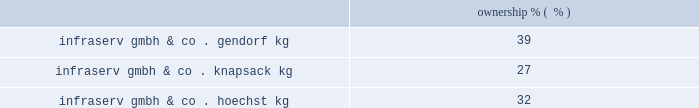Korea engineering plastics co. , ltd .
Founded in 1987 , kepco is the leading producer of pom in south korea .
Kepco is a venture between celanese's ticona business ( 50% ( 50 % ) ) , mitsubishi gas chemical company , inc .
( 40% ( 40 % ) ) and mitsubishi corporation ( 10% ( 10 % ) ) .
Kepco has polyacetal production facilities in ulsan , south korea , compounding facilities for pbt and nylon in pyongtaek , south korea , and participates with polyplastics and mitsubishi gas chemical company , inc .
In a world-scale pom facility in nantong , china .
Polyplastics co. , ltd .
Polyplastics is a leading supplier of engineered plastics in the asia-pacific region and is a venture between daicel chemical industries ltd. , japan ( 55% ( 55 % ) ) , and celanese's ticona business ( 45% ( 45 % ) ) .
Established in 1964 , polyplastics is a producer and marketer of pom and lcp in the asia-pacific region , with principal production facilities located in japan , taiwan , malaysia and china .
Fortron industries llc .
Fortron is a leading global producer of polyphenylene sulfide ( 201cpps 201d ) , sold under the fortron ae brand , which is used in a wide variety of automotive and other applications , especially those requiring heat and/or chemical resistance .
Established in 1992 , fortron is a limited liability company whose members are ticona fortron inc .
( 50% ( 50 % ) ownership and a wholly-owned subsidiary of cna holdings , llc ) and kureha corporation ( 50% ( 50 % ) ownership and a wholly-owned subsidiary of kureha chemical industry co. , ltd .
Of japan ) .
Fortron's facility is located in wilmington , north carolina .
This venture combines the sales , marketing , distribution , compounding and manufacturing expertise of celanese with the pps polymer technology expertise of kureha .
China acetate strategic ventures .
We hold an approximate 30% ( 30 % ) ownership interest in three separate acetate production ventures in china .
These include the nantong cellulose fibers co .
Ltd. , kunming cellulose fibers co .
Ltd .
And zhuhai cellulose fibers co .
Ltd .
The china national tobacco corporation , the chinese state-owned tobacco entity , controls the remaining ownership interest in each of these ventures .
With an estimated 30% ( 30 % ) share of the world's cigarette production and consumption , china is the world's largest and fastest growing area for acetate tow products according to the 2009 stanford research institute international chemical economics handbook .
Combined , these ventures are a leader in chinese domestic acetate production and are well positioned to supply chinese cigarette producers .
In december 2009 , we announced plans with china national tobacco to expand our acetate flake and tow capacity at our venture's nantong facility and we received formal approval for the expansions , each by 30000 tons , during 2010 .
Since their inception in 1986 , the china acetate ventures have completed 12 expansions , leading to earnings growth and increased dividends .
Our chinese acetate ventures fund their operations using operating cash flow .
During 2011 , we made contributions of $ 8 million related to the capacity expansions in nantong and have committed contributions of $ 9 million in 2012 .
In 2010 , we made contributions of $ 12 million .
Our chinese acetate ventures pay a dividend in the second quarter of each fiscal year , based on the ventures' performance for the preceding year .
In 2011 , 2010 and 2009 , we received cash dividends of $ 78 million , $ 71 million and $ 56 million , respectively .
Although our ownership interest in each of our china acetate ventures exceeds 20% ( 20 % ) , we account for these investments using the cost method of accounting because we determined that we cannot exercise significant influence over these entities due to local government investment in and influence over these entities , limitations on our involvement in the day-to-day operations and the present inability of the entities to provide timely financial information prepared in accordance with generally accepted accounting principles in the united states ( 201cus gaap 201d ) .
2022 other equity method investments infraservs .
We hold indirect ownership interests in several infraserv groups in germany that own and develop industrial parks and provide on-site general and administrative support to tenants .
The table below represents our equity investments in infraserv ventures as of december 31 , 2011: .

What was the percentage growth in the cash dividends from 2010 to 2011? 
Rationale: the percentage change is the difference from year to year divide by the earlier year balance
Computations: ((78 - 71) / 71)
Answer: 0.09859. 